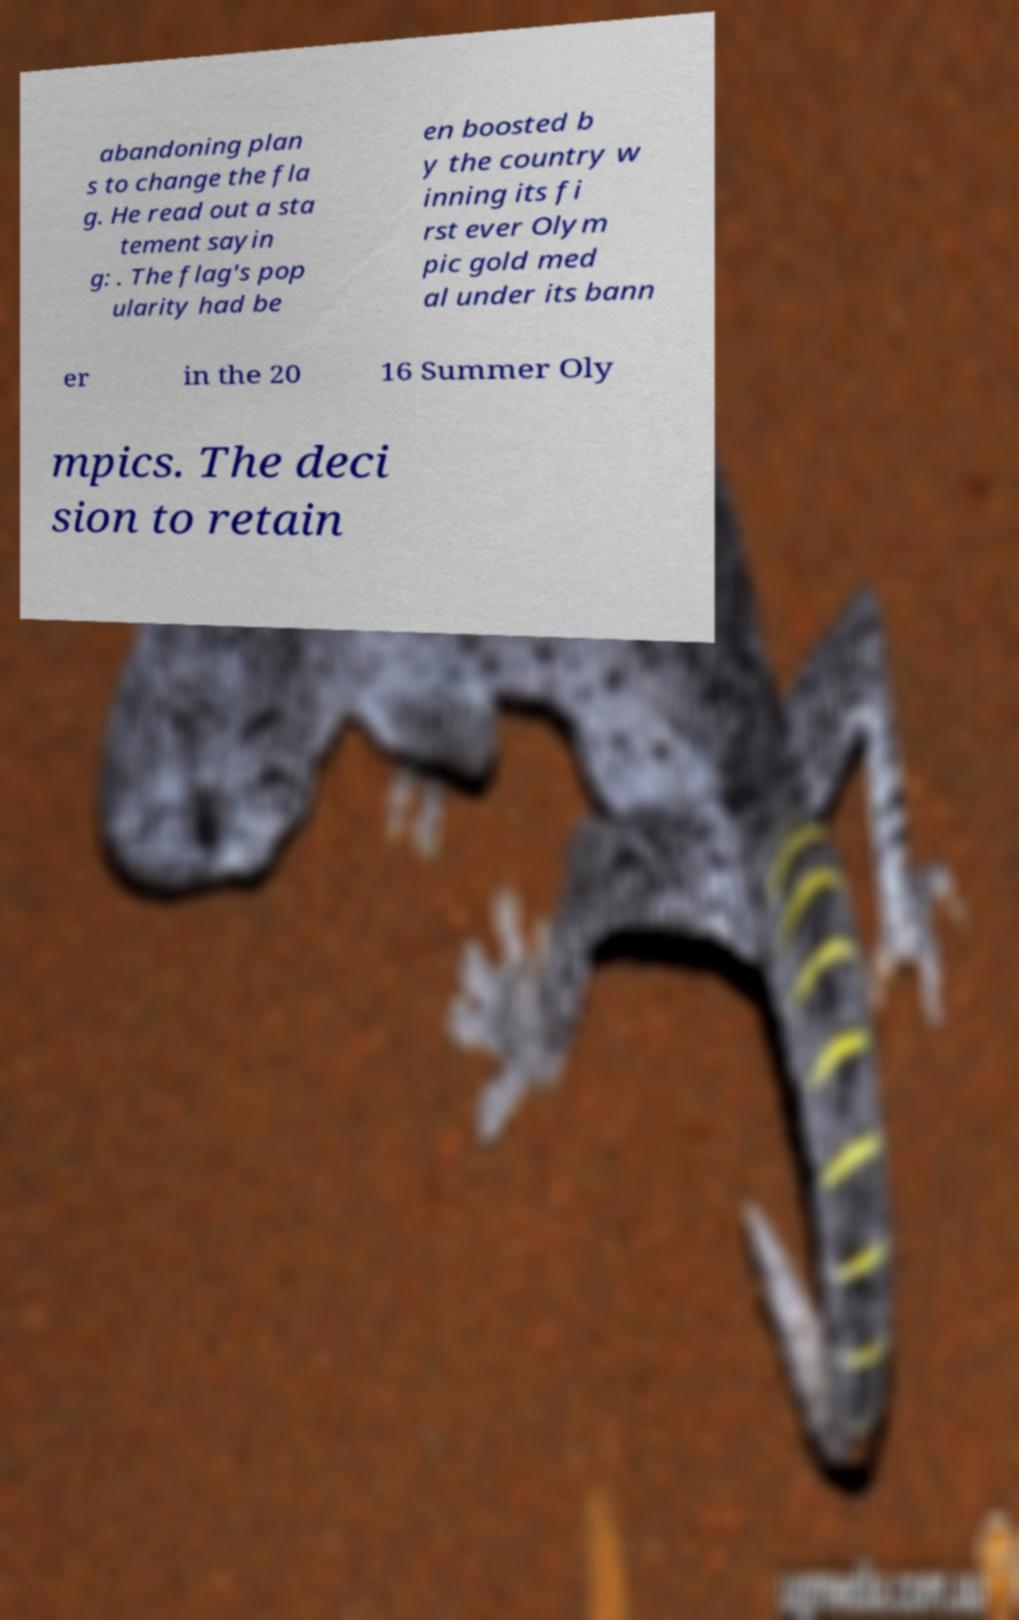Please identify and transcribe the text found in this image. abandoning plan s to change the fla g. He read out a sta tement sayin g: . The flag's pop ularity had be en boosted b y the country w inning its fi rst ever Olym pic gold med al under its bann er in the 20 16 Summer Oly mpics. The deci sion to retain 